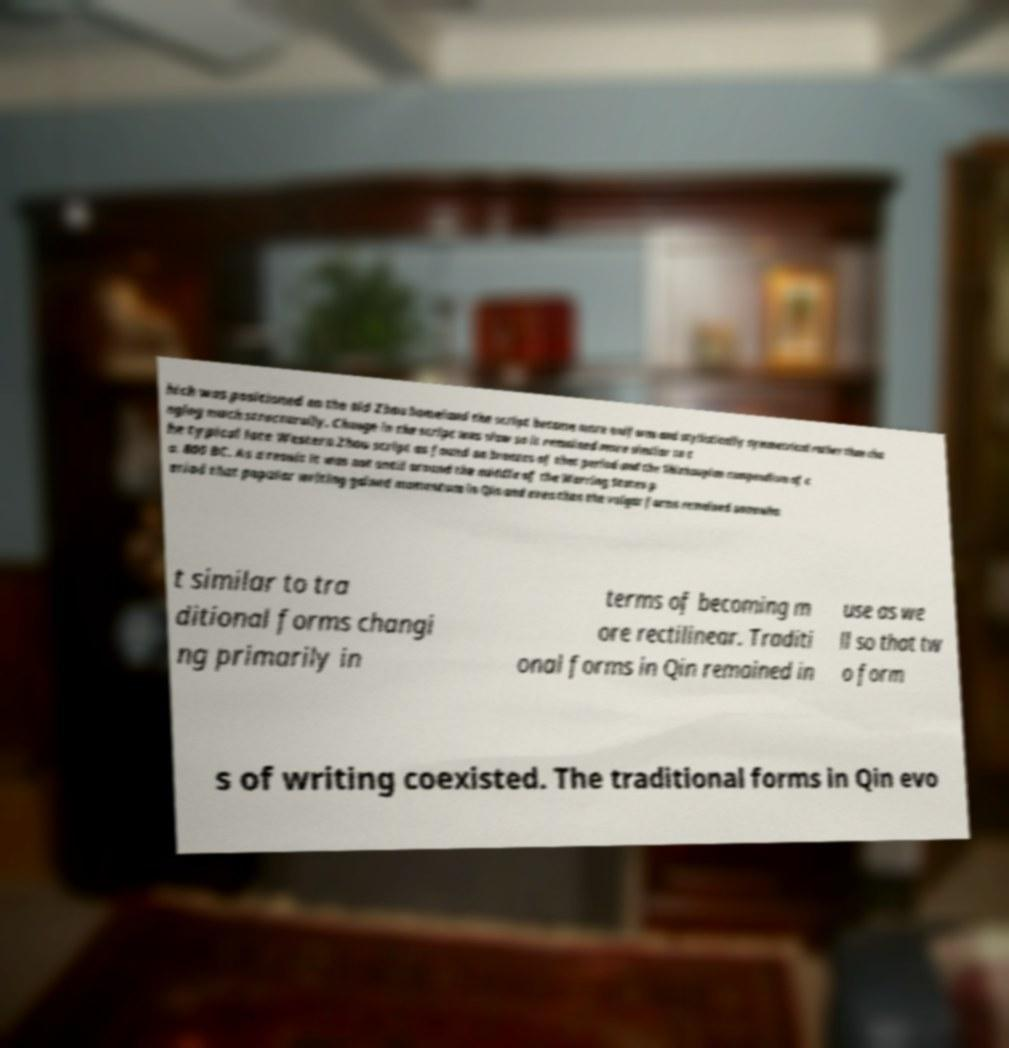There's text embedded in this image that I need extracted. Can you transcribe it verbatim? hich was positioned on the old Zhou homeland the script became more uniform and stylistically symmetrical rather than cha nging much structurally. Change in the script was slow so it remained more similar to t he typical late Western Zhou script as found on bronzes of that period and the Shizhoupian compendium of c a. 800 BC. As a result it was not until around the middle of the Warring States p eriod that popular writing gained momentum in Qin and even then the vulgar forms remained somewha t similar to tra ditional forms changi ng primarily in terms of becoming m ore rectilinear. Traditi onal forms in Qin remained in use as we ll so that tw o form s of writing coexisted. The traditional forms in Qin evo 